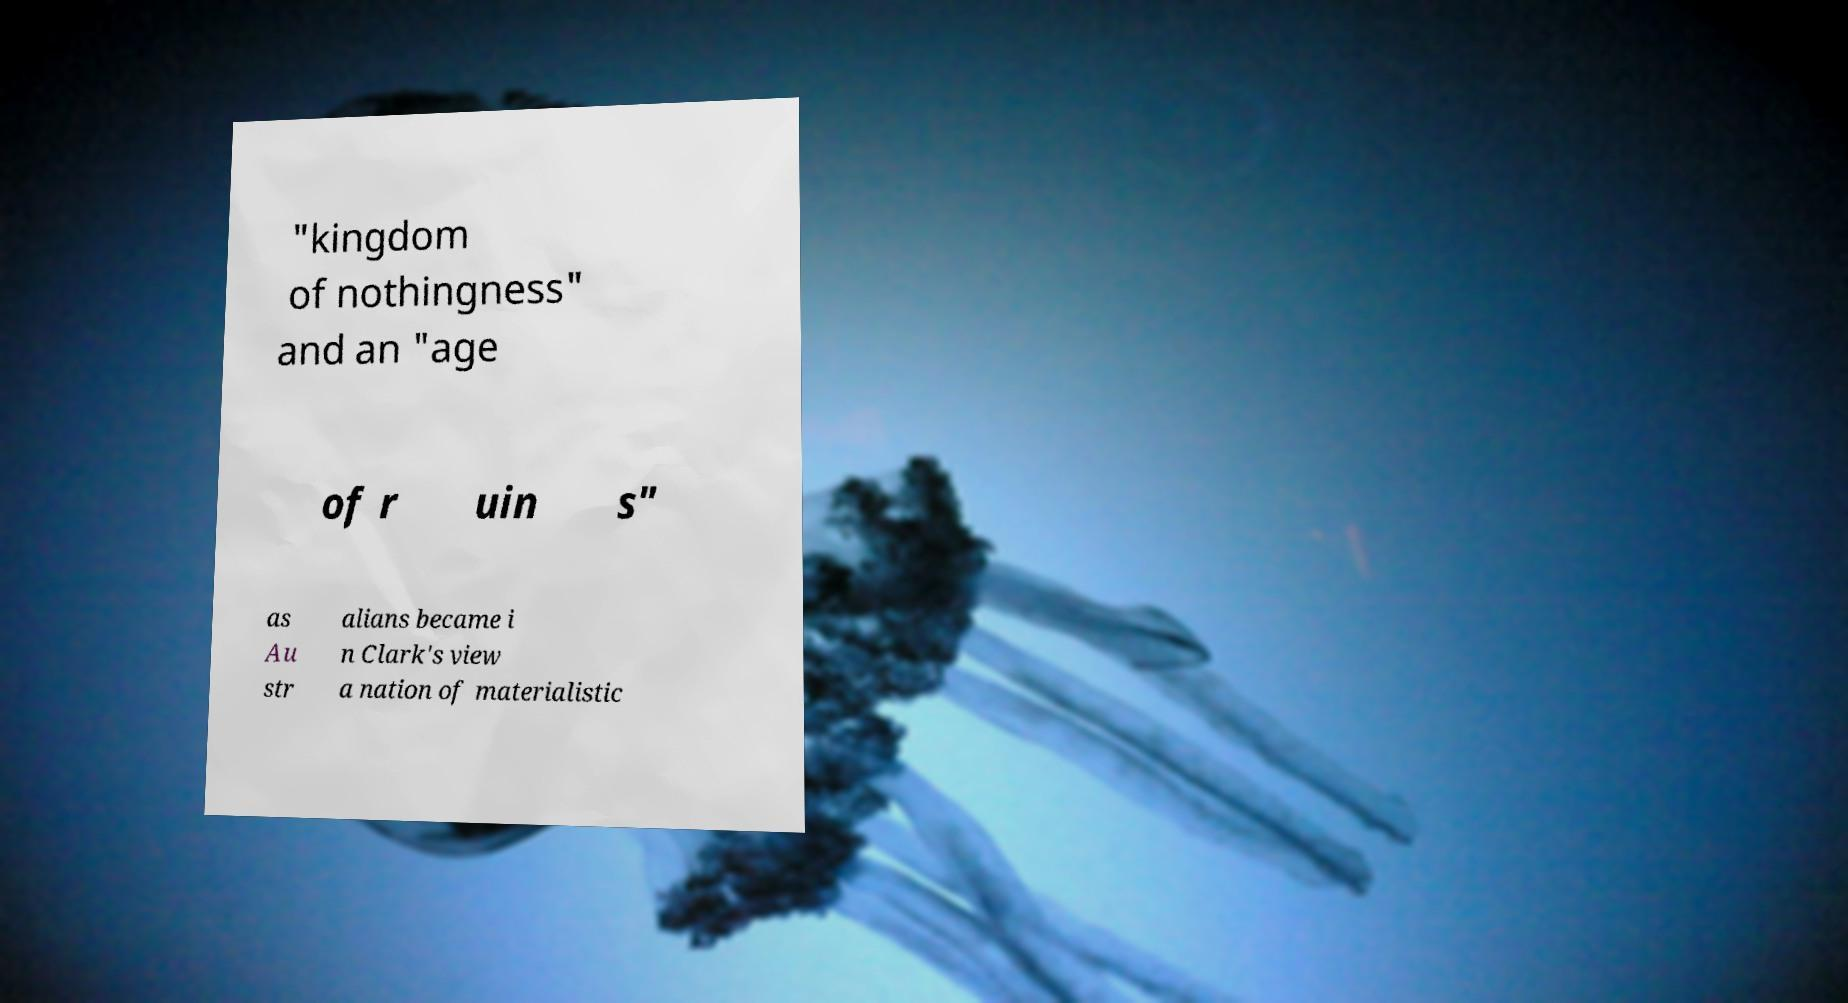For documentation purposes, I need the text within this image transcribed. Could you provide that? "kingdom of nothingness" and an "age of r uin s" as Au str alians became i n Clark's view a nation of materialistic 